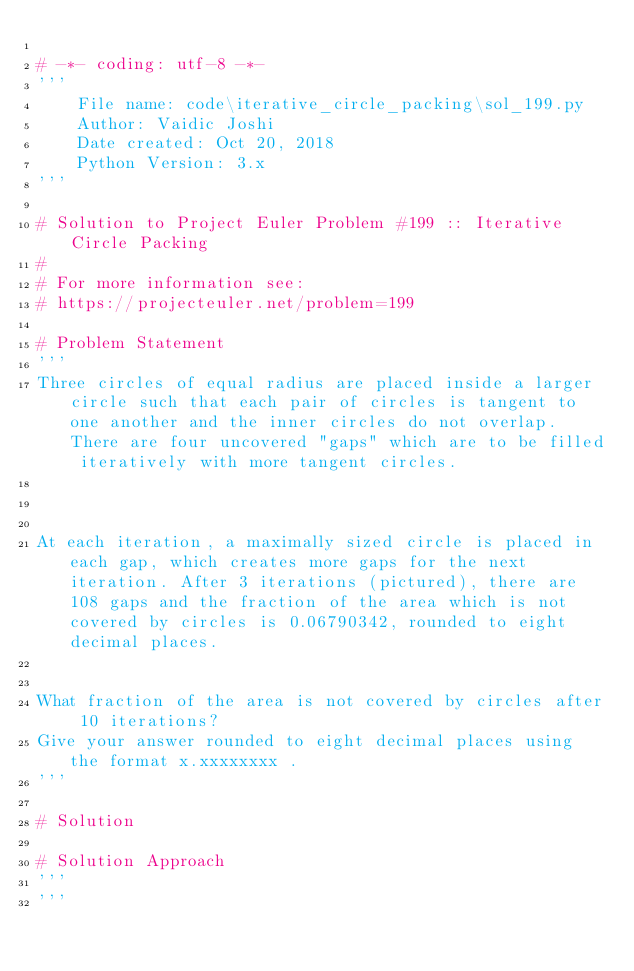Convert code to text. <code><loc_0><loc_0><loc_500><loc_500><_Python_>
# -*- coding: utf-8 -*-
'''
    File name: code\iterative_circle_packing\sol_199.py
    Author: Vaidic Joshi
    Date created: Oct 20, 2018
    Python Version: 3.x
'''

# Solution to Project Euler Problem #199 :: Iterative Circle Packing
# 
# For more information see:
# https://projecteuler.net/problem=199

# Problem Statement 
'''
Three circles of equal radius are placed inside a larger circle such that each pair of circles is tangent to one another and the inner circles do not overlap. There are four uncovered "gaps" which are to be filled iteratively with more tangent circles.



At each iteration, a maximally sized circle is placed in each gap, which creates more gaps for the next iteration. After 3 iterations (pictured), there are 108 gaps and the fraction of the area which is not covered by circles is 0.06790342, rounded to eight decimal places.


What fraction of the area is not covered by circles after 10 iterations?
Give your answer rounded to eight decimal places using the format x.xxxxxxxx .
'''

# Solution 

# Solution Approach 
'''
'''
</code> 